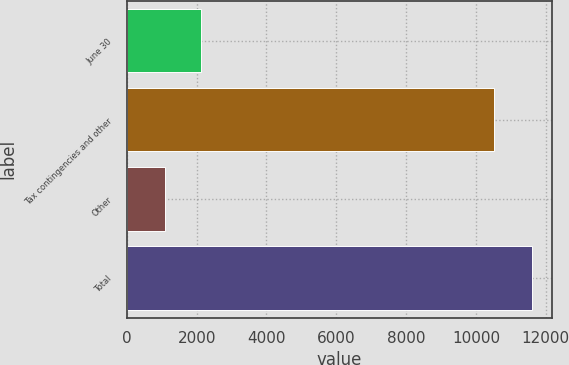Convert chart to OTSL. <chart><loc_0><loc_0><loc_500><loc_500><bar_chart><fcel>June 30<fcel>Tax contingencies and other<fcel>Other<fcel>Total<nl><fcel>2135<fcel>10510<fcel>1084<fcel>11594<nl></chart> 